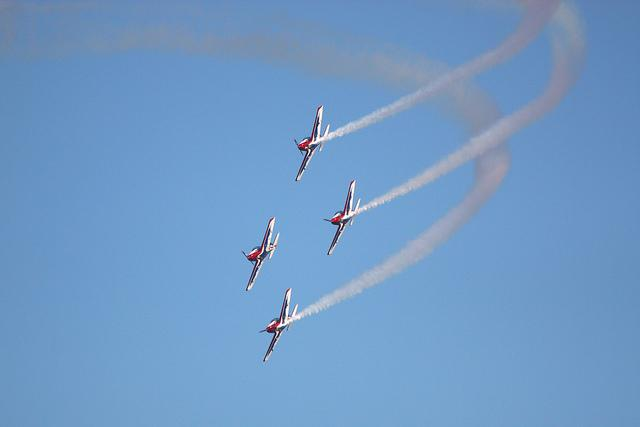The planes are executing a what?

Choices:
A) emergency landing
B) stunt formation
C) space flight
D) sky dive stunt formation 